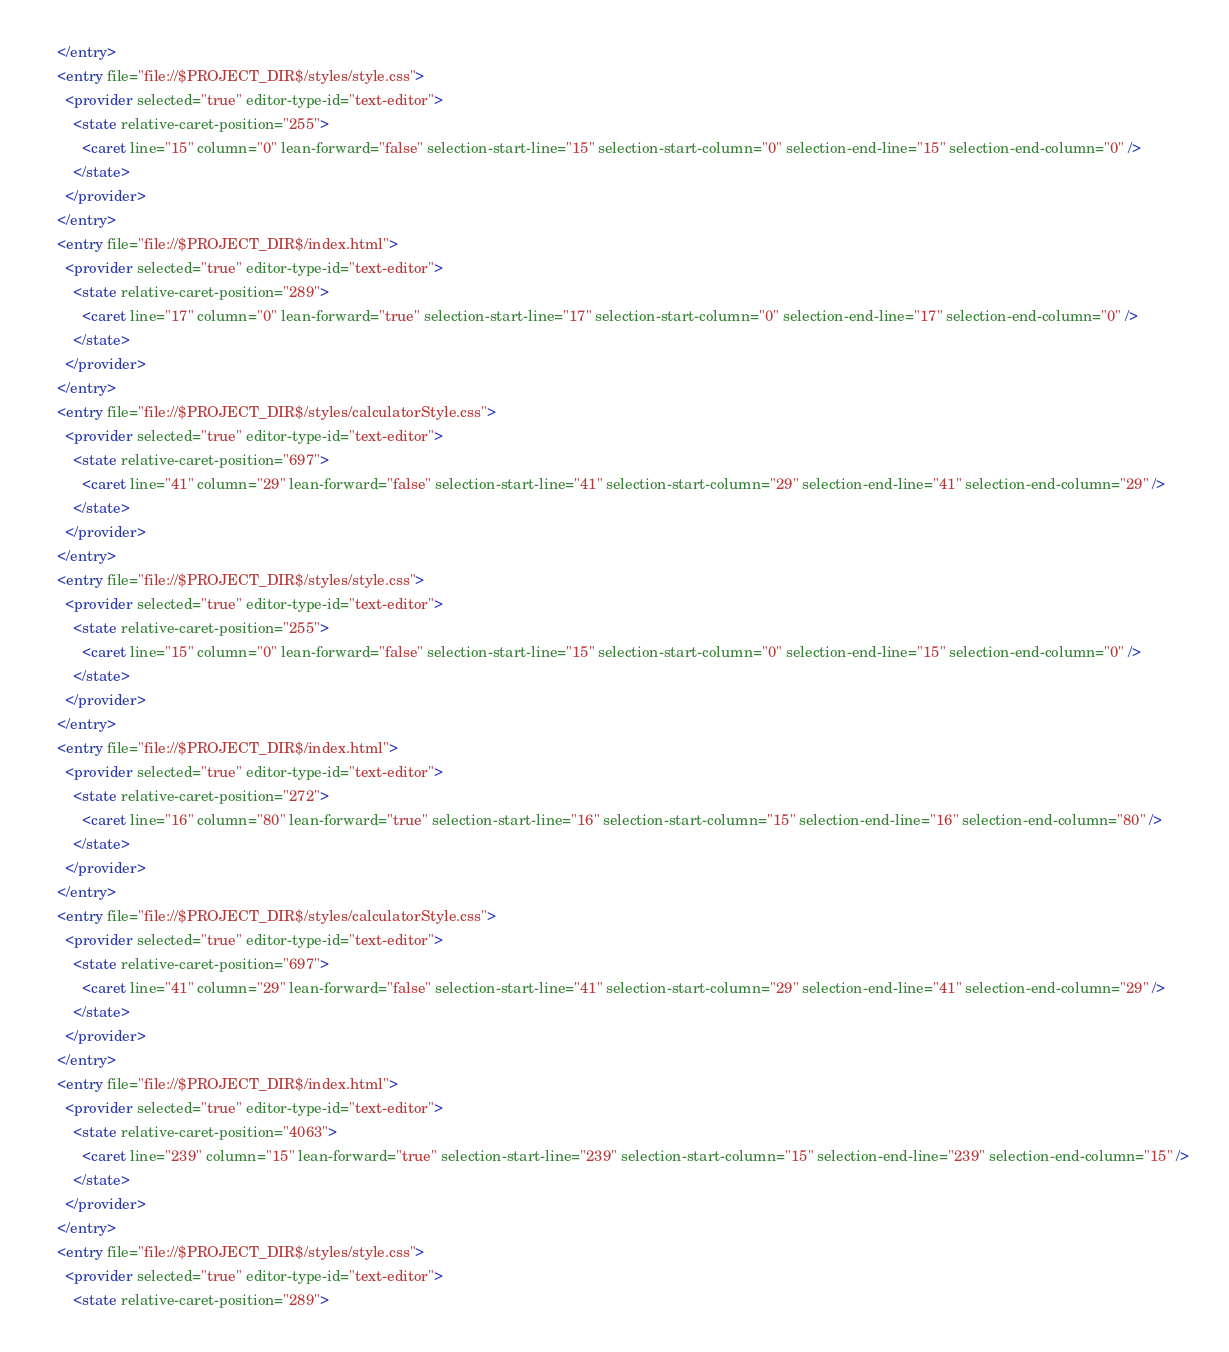Convert code to text. <code><loc_0><loc_0><loc_500><loc_500><_XML_>    </entry>
    <entry file="file://$PROJECT_DIR$/styles/style.css">
      <provider selected="true" editor-type-id="text-editor">
        <state relative-caret-position="255">
          <caret line="15" column="0" lean-forward="false" selection-start-line="15" selection-start-column="0" selection-end-line="15" selection-end-column="0" />
        </state>
      </provider>
    </entry>
    <entry file="file://$PROJECT_DIR$/index.html">
      <provider selected="true" editor-type-id="text-editor">
        <state relative-caret-position="289">
          <caret line="17" column="0" lean-forward="true" selection-start-line="17" selection-start-column="0" selection-end-line="17" selection-end-column="0" />
        </state>
      </provider>
    </entry>
    <entry file="file://$PROJECT_DIR$/styles/calculatorStyle.css">
      <provider selected="true" editor-type-id="text-editor">
        <state relative-caret-position="697">
          <caret line="41" column="29" lean-forward="false" selection-start-line="41" selection-start-column="29" selection-end-line="41" selection-end-column="29" />
        </state>
      </provider>
    </entry>
    <entry file="file://$PROJECT_DIR$/styles/style.css">
      <provider selected="true" editor-type-id="text-editor">
        <state relative-caret-position="255">
          <caret line="15" column="0" lean-forward="false" selection-start-line="15" selection-start-column="0" selection-end-line="15" selection-end-column="0" />
        </state>
      </provider>
    </entry>
    <entry file="file://$PROJECT_DIR$/index.html">
      <provider selected="true" editor-type-id="text-editor">
        <state relative-caret-position="272">
          <caret line="16" column="80" lean-forward="true" selection-start-line="16" selection-start-column="15" selection-end-line="16" selection-end-column="80" />
        </state>
      </provider>
    </entry>
    <entry file="file://$PROJECT_DIR$/styles/calculatorStyle.css">
      <provider selected="true" editor-type-id="text-editor">
        <state relative-caret-position="697">
          <caret line="41" column="29" lean-forward="false" selection-start-line="41" selection-start-column="29" selection-end-line="41" selection-end-column="29" />
        </state>
      </provider>
    </entry>
    <entry file="file://$PROJECT_DIR$/index.html">
      <provider selected="true" editor-type-id="text-editor">
        <state relative-caret-position="4063">
          <caret line="239" column="15" lean-forward="true" selection-start-line="239" selection-start-column="15" selection-end-line="239" selection-end-column="15" />
        </state>
      </provider>
    </entry>
    <entry file="file://$PROJECT_DIR$/styles/style.css">
      <provider selected="true" editor-type-id="text-editor">
        <state relative-caret-position="289"></code> 